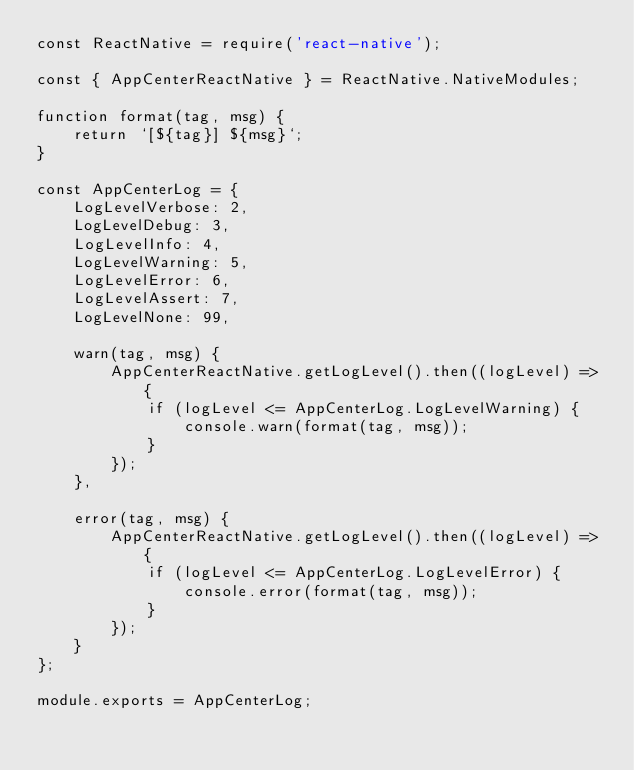<code> <loc_0><loc_0><loc_500><loc_500><_JavaScript_>const ReactNative = require('react-native');

const { AppCenterReactNative } = ReactNative.NativeModules;

function format(tag, msg) {
    return `[${tag}] ${msg}`;
}

const AppCenterLog = {
    LogLevelVerbose: 2,
    LogLevelDebug: 3,
    LogLevelInfo: 4,
    LogLevelWarning: 5,
    LogLevelError: 6,
    LogLevelAssert: 7,
    LogLevelNone: 99,

    warn(tag, msg) {
        AppCenterReactNative.getLogLevel().then((logLevel) => {
            if (logLevel <= AppCenterLog.LogLevelWarning) {
                console.warn(format(tag, msg));
            }
        });
    },

    error(tag, msg) {
        AppCenterReactNative.getLogLevel().then((logLevel) => {
            if (logLevel <= AppCenterLog.LogLevelError) {
                console.error(format(tag, msg));
            }
        });
    }
};

module.exports = AppCenterLog;
</code> 